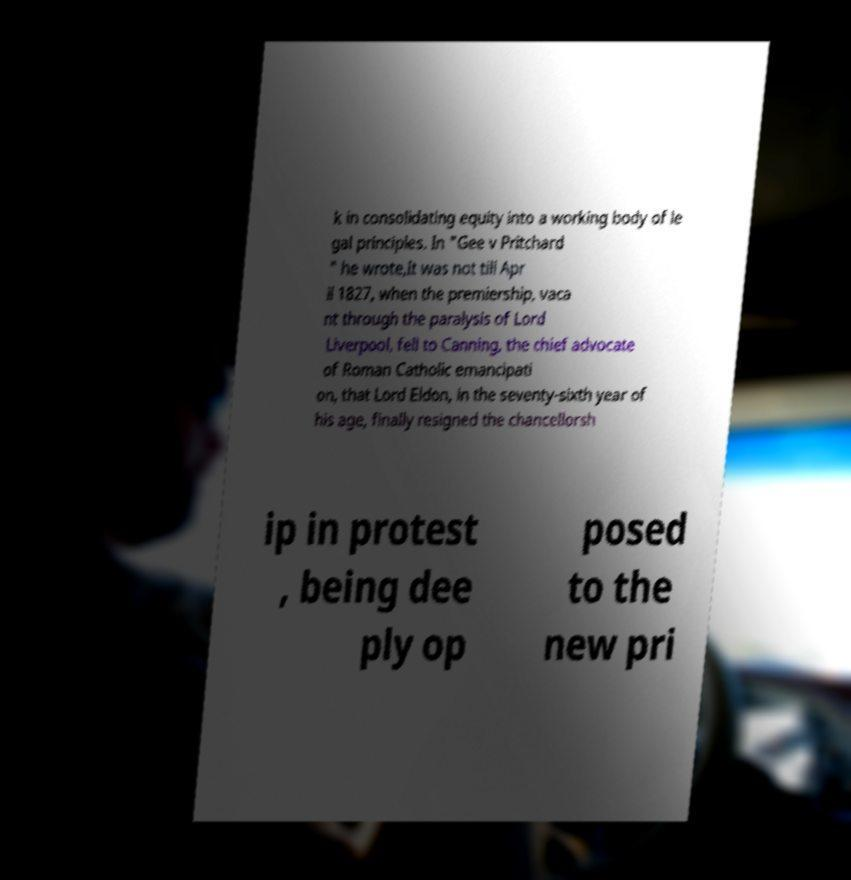I need the written content from this picture converted into text. Can you do that? k in consolidating equity into a working body of le gal principles. In "Gee v Pritchard " he wrote,It was not till Apr il 1827, when the premiership, vaca nt through the paralysis of Lord Liverpool, fell to Canning, the chief advocate of Roman Catholic emancipati on, that Lord Eldon, in the seventy-sixth year of his age, finally resigned the chancellorsh ip in protest , being dee ply op posed to the new pri 